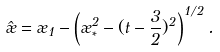Convert formula to latex. <formula><loc_0><loc_0><loc_500><loc_500>\hat { \rho } = \rho _ { 1 } - \left ( \rho _ { * } ^ { 2 } - ( t - \frac { 3 } { 2 } ) ^ { 2 } \right ) ^ { 1 / 2 } .</formula> 